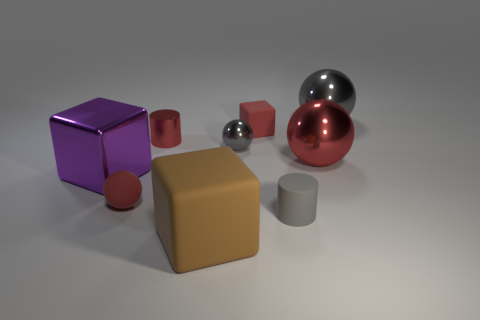Subtract all red blocks. How many gray balls are left? 2 Subtract all small red matte spheres. How many spheres are left? 3 Subtract 1 spheres. How many spheres are left? 3 Subtract all cyan balls. Subtract all gray cylinders. How many balls are left? 4 Subtract all cubes. How many objects are left? 6 Add 1 big matte things. How many big matte things are left? 2 Add 4 large yellow shiny things. How many large yellow shiny things exist? 4 Subtract 0 cyan cylinders. How many objects are left? 9 Subtract all big yellow matte objects. Subtract all tiny rubber things. How many objects are left? 6 